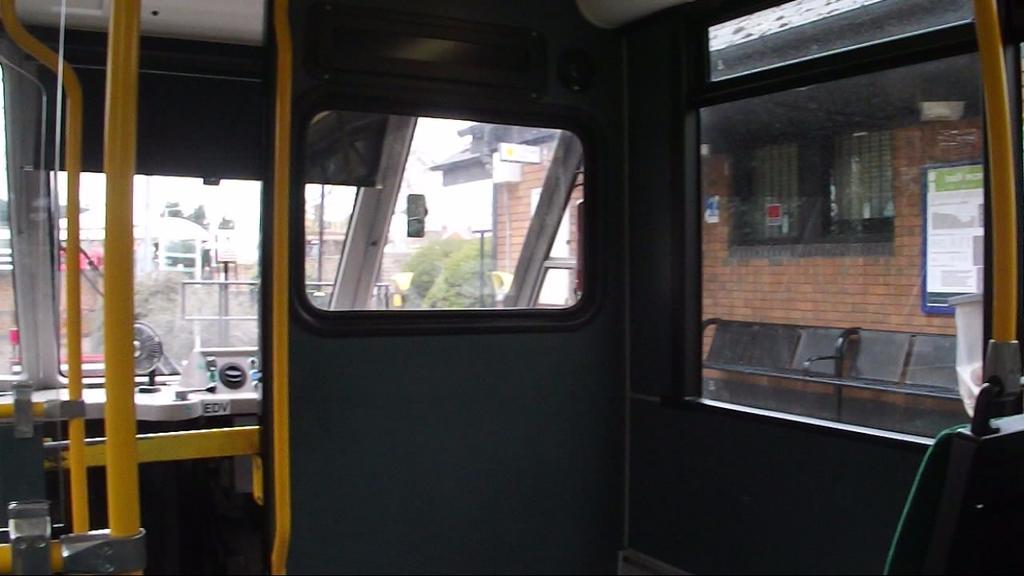Describe this image in one or two sentences. In this image we can see inside of a vehicle. There are few buildings and houses in the image. There are many trees in the image. There are few advertising boards in the image. There is a sky in the image. There are few chairs in the image. 